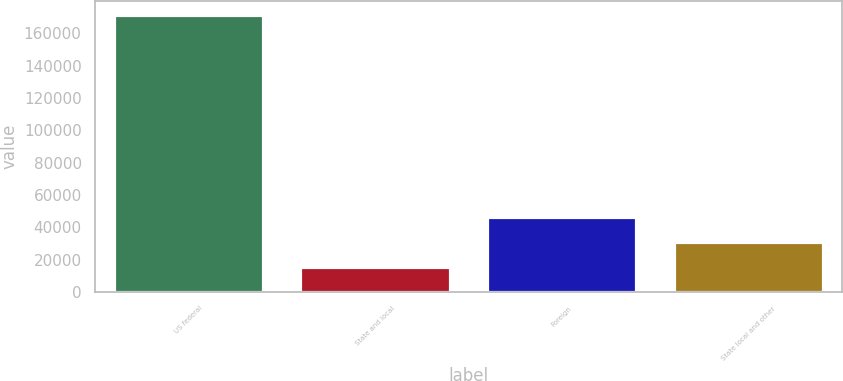Convert chart to OTSL. <chart><loc_0><loc_0><loc_500><loc_500><bar_chart><fcel>US federal<fcel>State and local<fcel>Foreign<fcel>State local and other<nl><fcel>171122<fcel>15388<fcel>46534.8<fcel>30961.4<nl></chart> 